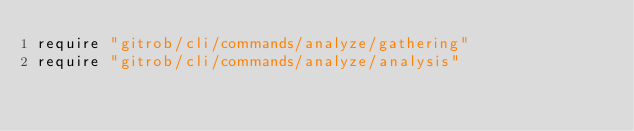<code> <loc_0><loc_0><loc_500><loc_500><_Ruby_>require "gitrob/cli/commands/analyze/gathering"
require "gitrob/cli/commands/analyze/analysis"
</code> 